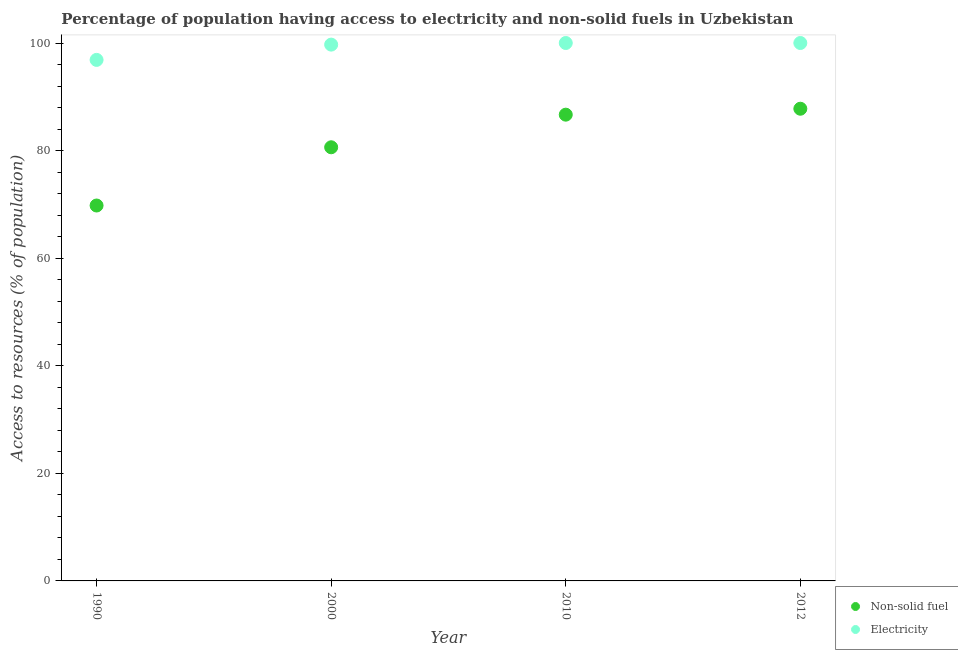What is the percentage of population having access to electricity in 2000?
Your answer should be compact. 99.7. Across all years, what is the maximum percentage of population having access to electricity?
Provide a succinct answer. 100. Across all years, what is the minimum percentage of population having access to non-solid fuel?
Your response must be concise. 69.79. In which year was the percentage of population having access to non-solid fuel minimum?
Keep it short and to the point. 1990. What is the total percentage of population having access to non-solid fuel in the graph?
Provide a short and direct response. 324.86. What is the difference between the percentage of population having access to electricity in 1990 and that in 2012?
Provide a short and direct response. -3.14. What is the difference between the percentage of population having access to electricity in 2010 and the percentage of population having access to non-solid fuel in 2012?
Provide a short and direct response. 12.22. What is the average percentage of population having access to non-solid fuel per year?
Provide a short and direct response. 81.22. In the year 2000, what is the difference between the percentage of population having access to electricity and percentage of population having access to non-solid fuel?
Make the answer very short. 19.08. In how many years, is the percentage of population having access to electricity greater than 88 %?
Keep it short and to the point. 4. What is the ratio of the percentage of population having access to non-solid fuel in 2010 to that in 2012?
Your answer should be very brief. 0.99. Is the difference between the percentage of population having access to non-solid fuel in 1990 and 2012 greater than the difference between the percentage of population having access to electricity in 1990 and 2012?
Your answer should be compact. No. What is the difference between the highest and the second highest percentage of population having access to electricity?
Make the answer very short. 0. What is the difference between the highest and the lowest percentage of population having access to electricity?
Your answer should be compact. 3.14. In how many years, is the percentage of population having access to non-solid fuel greater than the average percentage of population having access to non-solid fuel taken over all years?
Your answer should be compact. 2. Is the percentage of population having access to non-solid fuel strictly less than the percentage of population having access to electricity over the years?
Provide a short and direct response. Yes. How many dotlines are there?
Provide a short and direct response. 2. What is the difference between two consecutive major ticks on the Y-axis?
Offer a terse response. 20. Does the graph contain any zero values?
Ensure brevity in your answer.  No. Does the graph contain grids?
Make the answer very short. No. Where does the legend appear in the graph?
Offer a terse response. Bottom right. How are the legend labels stacked?
Give a very brief answer. Vertical. What is the title of the graph?
Provide a short and direct response. Percentage of population having access to electricity and non-solid fuels in Uzbekistan. Does "Short-term debt" appear as one of the legend labels in the graph?
Make the answer very short. No. What is the label or title of the X-axis?
Make the answer very short. Year. What is the label or title of the Y-axis?
Offer a terse response. Access to resources (% of population). What is the Access to resources (% of population) in Non-solid fuel in 1990?
Make the answer very short. 69.79. What is the Access to resources (% of population) in Electricity in 1990?
Your answer should be compact. 96.86. What is the Access to resources (% of population) in Non-solid fuel in 2000?
Make the answer very short. 80.62. What is the Access to resources (% of population) of Electricity in 2000?
Your response must be concise. 99.7. What is the Access to resources (% of population) in Non-solid fuel in 2010?
Offer a very short reply. 86.68. What is the Access to resources (% of population) of Non-solid fuel in 2012?
Offer a terse response. 87.78. Across all years, what is the maximum Access to resources (% of population) in Non-solid fuel?
Give a very brief answer. 87.78. Across all years, what is the maximum Access to resources (% of population) in Electricity?
Offer a very short reply. 100. Across all years, what is the minimum Access to resources (% of population) in Non-solid fuel?
Offer a terse response. 69.79. Across all years, what is the minimum Access to resources (% of population) of Electricity?
Provide a short and direct response. 96.86. What is the total Access to resources (% of population) of Non-solid fuel in the graph?
Give a very brief answer. 324.86. What is the total Access to resources (% of population) in Electricity in the graph?
Your answer should be very brief. 396.56. What is the difference between the Access to resources (% of population) of Non-solid fuel in 1990 and that in 2000?
Provide a succinct answer. -10.83. What is the difference between the Access to resources (% of population) in Electricity in 1990 and that in 2000?
Keep it short and to the point. -2.84. What is the difference between the Access to resources (% of population) of Non-solid fuel in 1990 and that in 2010?
Provide a succinct answer. -16.89. What is the difference between the Access to resources (% of population) in Electricity in 1990 and that in 2010?
Ensure brevity in your answer.  -3.14. What is the difference between the Access to resources (% of population) of Non-solid fuel in 1990 and that in 2012?
Your answer should be very brief. -17.99. What is the difference between the Access to resources (% of population) of Electricity in 1990 and that in 2012?
Your answer should be compact. -3.14. What is the difference between the Access to resources (% of population) in Non-solid fuel in 2000 and that in 2010?
Your response must be concise. -6.06. What is the difference between the Access to resources (% of population) in Non-solid fuel in 2000 and that in 2012?
Provide a succinct answer. -7.16. What is the difference between the Access to resources (% of population) in Electricity in 2000 and that in 2012?
Your answer should be very brief. -0.3. What is the difference between the Access to resources (% of population) of Non-solid fuel in 2010 and that in 2012?
Your answer should be very brief. -1.1. What is the difference between the Access to resources (% of population) in Non-solid fuel in 1990 and the Access to resources (% of population) in Electricity in 2000?
Your answer should be very brief. -29.91. What is the difference between the Access to resources (% of population) of Non-solid fuel in 1990 and the Access to resources (% of population) of Electricity in 2010?
Ensure brevity in your answer.  -30.21. What is the difference between the Access to resources (% of population) in Non-solid fuel in 1990 and the Access to resources (% of population) in Electricity in 2012?
Your response must be concise. -30.21. What is the difference between the Access to resources (% of population) in Non-solid fuel in 2000 and the Access to resources (% of population) in Electricity in 2010?
Offer a terse response. -19.38. What is the difference between the Access to resources (% of population) of Non-solid fuel in 2000 and the Access to resources (% of population) of Electricity in 2012?
Offer a very short reply. -19.38. What is the difference between the Access to resources (% of population) in Non-solid fuel in 2010 and the Access to resources (% of population) in Electricity in 2012?
Your answer should be compact. -13.32. What is the average Access to resources (% of population) of Non-solid fuel per year?
Provide a succinct answer. 81.22. What is the average Access to resources (% of population) in Electricity per year?
Offer a terse response. 99.14. In the year 1990, what is the difference between the Access to resources (% of population) in Non-solid fuel and Access to resources (% of population) in Electricity?
Make the answer very short. -27.07. In the year 2000, what is the difference between the Access to resources (% of population) of Non-solid fuel and Access to resources (% of population) of Electricity?
Provide a short and direct response. -19.08. In the year 2010, what is the difference between the Access to resources (% of population) of Non-solid fuel and Access to resources (% of population) of Electricity?
Your answer should be compact. -13.32. In the year 2012, what is the difference between the Access to resources (% of population) in Non-solid fuel and Access to resources (% of population) in Electricity?
Your response must be concise. -12.22. What is the ratio of the Access to resources (% of population) of Non-solid fuel in 1990 to that in 2000?
Your response must be concise. 0.87. What is the ratio of the Access to resources (% of population) of Electricity in 1990 to that in 2000?
Offer a terse response. 0.97. What is the ratio of the Access to resources (% of population) in Non-solid fuel in 1990 to that in 2010?
Offer a very short reply. 0.81. What is the ratio of the Access to resources (% of population) in Electricity in 1990 to that in 2010?
Offer a very short reply. 0.97. What is the ratio of the Access to resources (% of population) of Non-solid fuel in 1990 to that in 2012?
Make the answer very short. 0.8. What is the ratio of the Access to resources (% of population) of Electricity in 1990 to that in 2012?
Offer a terse response. 0.97. What is the ratio of the Access to resources (% of population) in Non-solid fuel in 2000 to that in 2010?
Keep it short and to the point. 0.93. What is the ratio of the Access to resources (% of population) of Non-solid fuel in 2000 to that in 2012?
Your response must be concise. 0.92. What is the ratio of the Access to resources (% of population) in Non-solid fuel in 2010 to that in 2012?
Give a very brief answer. 0.99. What is the difference between the highest and the second highest Access to resources (% of population) of Non-solid fuel?
Offer a terse response. 1.1. What is the difference between the highest and the lowest Access to resources (% of population) of Non-solid fuel?
Offer a terse response. 17.99. What is the difference between the highest and the lowest Access to resources (% of population) in Electricity?
Offer a terse response. 3.14. 